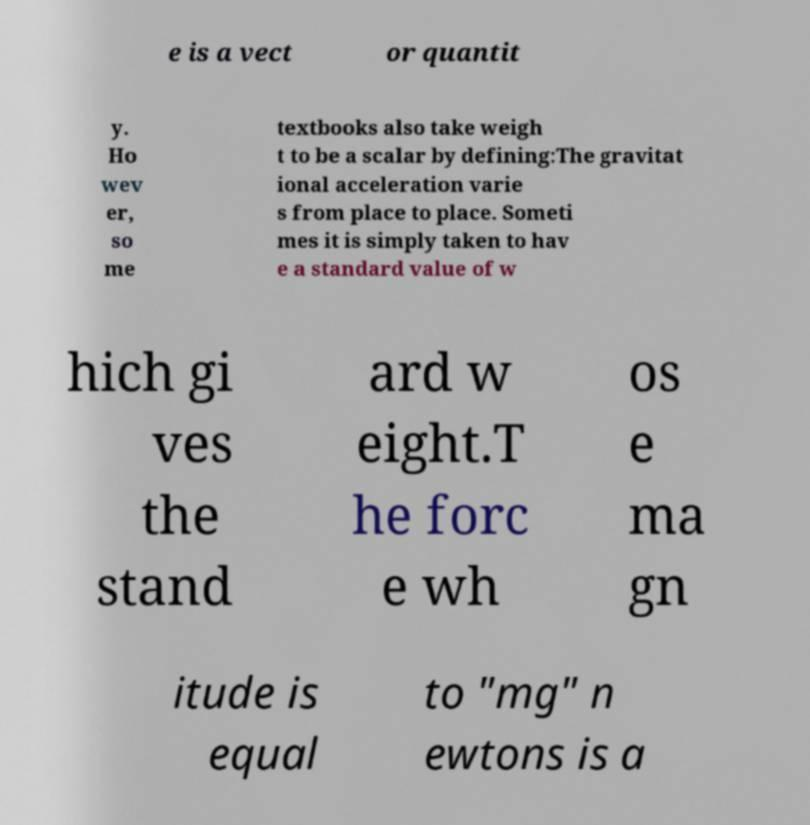Please read and relay the text visible in this image. What does it say? The text in the image is cut off and somewhat disjointed, but it discusses concepts of weight, standardizing weight values, and the force magnitude of 'mg' newtons being a vector or scalar quantity. The usable text seems to address inconsistencies or variations in how gravitational acceleration—and subsequently weight—is defined or calculated. 